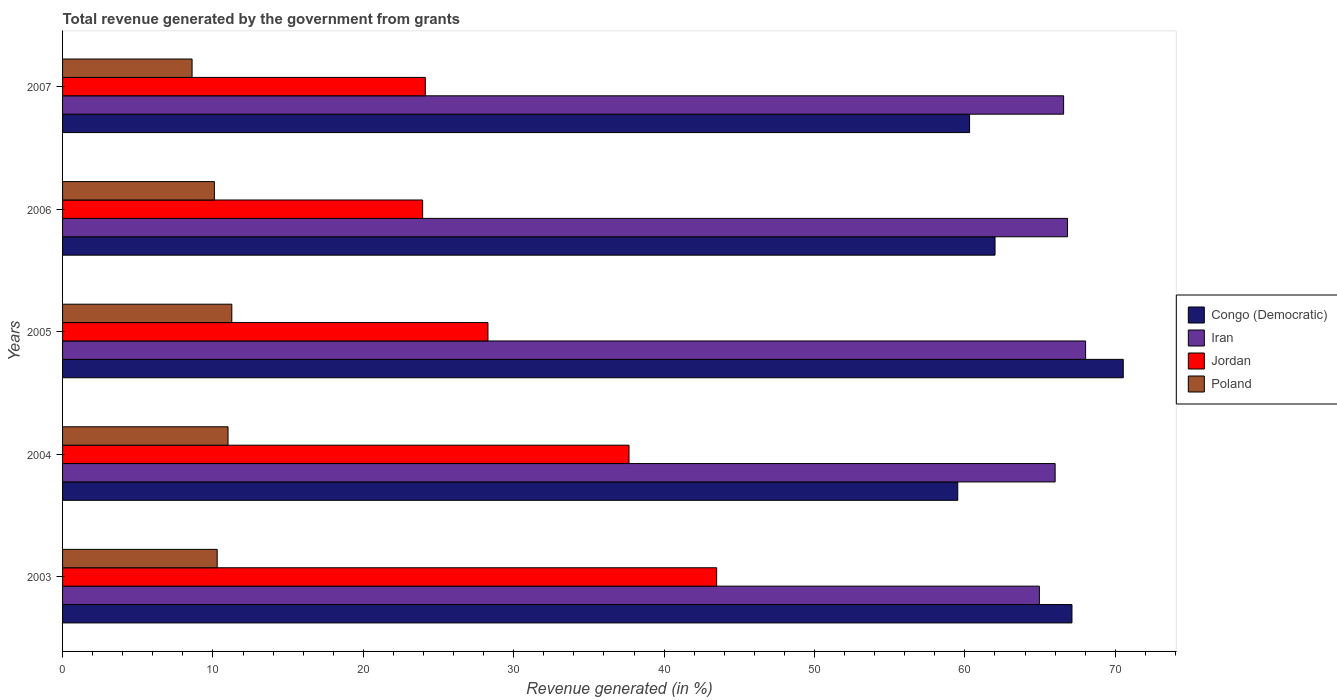Are the number of bars per tick equal to the number of legend labels?
Ensure brevity in your answer.  Yes. How many bars are there on the 5th tick from the top?
Ensure brevity in your answer.  4. How many bars are there on the 1st tick from the bottom?
Keep it short and to the point. 4. What is the label of the 3rd group of bars from the top?
Give a very brief answer. 2005. In how many cases, is the number of bars for a given year not equal to the number of legend labels?
Provide a short and direct response. 0. What is the total revenue generated in Iran in 2006?
Provide a succinct answer. 66.83. Across all years, what is the maximum total revenue generated in Congo (Democratic)?
Offer a terse response. 70.53. Across all years, what is the minimum total revenue generated in Congo (Democratic)?
Provide a short and direct response. 59.53. In which year was the total revenue generated in Congo (Democratic) minimum?
Offer a terse response. 2004. What is the total total revenue generated in Jordan in the graph?
Your response must be concise. 157.51. What is the difference between the total revenue generated in Poland in 2004 and that in 2005?
Your answer should be compact. -0.25. What is the difference between the total revenue generated in Congo (Democratic) in 2004 and the total revenue generated in Jordan in 2007?
Ensure brevity in your answer.  35.41. What is the average total revenue generated in Poland per year?
Ensure brevity in your answer.  10.25. In the year 2004, what is the difference between the total revenue generated in Jordan and total revenue generated in Congo (Democratic)?
Provide a short and direct response. -21.86. In how many years, is the total revenue generated in Poland greater than 48 %?
Offer a terse response. 0. What is the ratio of the total revenue generated in Poland in 2005 to that in 2006?
Ensure brevity in your answer.  1.11. Is the total revenue generated in Iran in 2003 less than that in 2005?
Your response must be concise. Yes. What is the difference between the highest and the second highest total revenue generated in Jordan?
Provide a succinct answer. 5.83. What is the difference between the highest and the lowest total revenue generated in Iran?
Ensure brevity in your answer.  3.07. Is the sum of the total revenue generated in Iran in 2005 and 2006 greater than the maximum total revenue generated in Jordan across all years?
Offer a very short reply. Yes. Is it the case that in every year, the sum of the total revenue generated in Iran and total revenue generated in Poland is greater than the sum of total revenue generated in Congo (Democratic) and total revenue generated in Jordan?
Offer a terse response. No. What does the 1st bar from the top in 2003 represents?
Offer a terse response. Poland. How many bars are there?
Your response must be concise. 20. Are all the bars in the graph horizontal?
Offer a terse response. Yes. How many years are there in the graph?
Offer a very short reply. 5. Are the values on the major ticks of X-axis written in scientific E-notation?
Your answer should be compact. No. How many legend labels are there?
Keep it short and to the point. 4. What is the title of the graph?
Give a very brief answer. Total revenue generated by the government from grants. What is the label or title of the X-axis?
Your answer should be very brief. Revenue generated (in %). What is the label or title of the Y-axis?
Give a very brief answer. Years. What is the Revenue generated (in %) of Congo (Democratic) in 2003?
Provide a succinct answer. 67.12. What is the Revenue generated (in %) of Iran in 2003?
Offer a very short reply. 64.95. What is the Revenue generated (in %) in Jordan in 2003?
Make the answer very short. 43.49. What is the Revenue generated (in %) of Poland in 2003?
Your answer should be compact. 10.28. What is the Revenue generated (in %) in Congo (Democratic) in 2004?
Make the answer very short. 59.53. What is the Revenue generated (in %) of Iran in 2004?
Your answer should be very brief. 66. What is the Revenue generated (in %) of Jordan in 2004?
Offer a very short reply. 37.67. What is the Revenue generated (in %) in Poland in 2004?
Give a very brief answer. 11. What is the Revenue generated (in %) of Congo (Democratic) in 2005?
Your answer should be very brief. 70.53. What is the Revenue generated (in %) in Iran in 2005?
Keep it short and to the point. 68.03. What is the Revenue generated (in %) in Jordan in 2005?
Give a very brief answer. 28.29. What is the Revenue generated (in %) in Poland in 2005?
Provide a succinct answer. 11.25. What is the Revenue generated (in %) of Congo (Democratic) in 2006?
Make the answer very short. 62.01. What is the Revenue generated (in %) in Iran in 2006?
Make the answer very short. 66.83. What is the Revenue generated (in %) in Jordan in 2006?
Your response must be concise. 23.94. What is the Revenue generated (in %) in Poland in 2006?
Keep it short and to the point. 10.09. What is the Revenue generated (in %) in Congo (Democratic) in 2007?
Your answer should be very brief. 60.31. What is the Revenue generated (in %) in Iran in 2007?
Offer a very short reply. 66.57. What is the Revenue generated (in %) of Jordan in 2007?
Keep it short and to the point. 24.12. What is the Revenue generated (in %) of Poland in 2007?
Keep it short and to the point. 8.61. Across all years, what is the maximum Revenue generated (in %) of Congo (Democratic)?
Your answer should be very brief. 70.53. Across all years, what is the maximum Revenue generated (in %) of Iran?
Your answer should be compact. 68.03. Across all years, what is the maximum Revenue generated (in %) of Jordan?
Your response must be concise. 43.49. Across all years, what is the maximum Revenue generated (in %) of Poland?
Ensure brevity in your answer.  11.25. Across all years, what is the minimum Revenue generated (in %) of Congo (Democratic)?
Your answer should be very brief. 59.53. Across all years, what is the minimum Revenue generated (in %) in Iran?
Your response must be concise. 64.95. Across all years, what is the minimum Revenue generated (in %) in Jordan?
Your answer should be very brief. 23.94. Across all years, what is the minimum Revenue generated (in %) of Poland?
Provide a short and direct response. 8.61. What is the total Revenue generated (in %) in Congo (Democratic) in the graph?
Make the answer very short. 319.5. What is the total Revenue generated (in %) in Iran in the graph?
Provide a succinct answer. 332.37. What is the total Revenue generated (in %) of Jordan in the graph?
Give a very brief answer. 157.51. What is the total Revenue generated (in %) of Poland in the graph?
Your response must be concise. 51.24. What is the difference between the Revenue generated (in %) in Congo (Democratic) in 2003 and that in 2004?
Keep it short and to the point. 7.59. What is the difference between the Revenue generated (in %) in Iran in 2003 and that in 2004?
Give a very brief answer. -1.05. What is the difference between the Revenue generated (in %) of Jordan in 2003 and that in 2004?
Your answer should be very brief. 5.83. What is the difference between the Revenue generated (in %) in Poland in 2003 and that in 2004?
Your response must be concise. -0.72. What is the difference between the Revenue generated (in %) of Congo (Democratic) in 2003 and that in 2005?
Offer a terse response. -3.41. What is the difference between the Revenue generated (in %) of Iran in 2003 and that in 2005?
Provide a succinct answer. -3.07. What is the difference between the Revenue generated (in %) in Jordan in 2003 and that in 2005?
Your response must be concise. 15.21. What is the difference between the Revenue generated (in %) in Poland in 2003 and that in 2005?
Offer a terse response. -0.97. What is the difference between the Revenue generated (in %) in Congo (Democratic) in 2003 and that in 2006?
Provide a succinct answer. 5.12. What is the difference between the Revenue generated (in %) in Iran in 2003 and that in 2006?
Make the answer very short. -1.87. What is the difference between the Revenue generated (in %) of Jordan in 2003 and that in 2006?
Your response must be concise. 19.55. What is the difference between the Revenue generated (in %) of Poland in 2003 and that in 2006?
Your answer should be very brief. 0.19. What is the difference between the Revenue generated (in %) in Congo (Democratic) in 2003 and that in 2007?
Keep it short and to the point. 6.81. What is the difference between the Revenue generated (in %) of Iran in 2003 and that in 2007?
Keep it short and to the point. -1.61. What is the difference between the Revenue generated (in %) of Jordan in 2003 and that in 2007?
Keep it short and to the point. 19.37. What is the difference between the Revenue generated (in %) of Poland in 2003 and that in 2007?
Your answer should be very brief. 1.67. What is the difference between the Revenue generated (in %) of Congo (Democratic) in 2004 and that in 2005?
Keep it short and to the point. -11.01. What is the difference between the Revenue generated (in %) of Iran in 2004 and that in 2005?
Your answer should be very brief. -2.03. What is the difference between the Revenue generated (in %) in Jordan in 2004 and that in 2005?
Your response must be concise. 9.38. What is the difference between the Revenue generated (in %) in Poland in 2004 and that in 2005?
Give a very brief answer. -0.25. What is the difference between the Revenue generated (in %) in Congo (Democratic) in 2004 and that in 2006?
Give a very brief answer. -2.48. What is the difference between the Revenue generated (in %) in Iran in 2004 and that in 2006?
Provide a short and direct response. -0.82. What is the difference between the Revenue generated (in %) of Jordan in 2004 and that in 2006?
Your response must be concise. 13.72. What is the difference between the Revenue generated (in %) in Poland in 2004 and that in 2006?
Offer a very short reply. 0.91. What is the difference between the Revenue generated (in %) in Congo (Democratic) in 2004 and that in 2007?
Offer a terse response. -0.78. What is the difference between the Revenue generated (in %) in Iran in 2004 and that in 2007?
Ensure brevity in your answer.  -0.56. What is the difference between the Revenue generated (in %) in Jordan in 2004 and that in 2007?
Your response must be concise. 13.54. What is the difference between the Revenue generated (in %) in Poland in 2004 and that in 2007?
Offer a very short reply. 2.39. What is the difference between the Revenue generated (in %) of Congo (Democratic) in 2005 and that in 2006?
Provide a short and direct response. 8.53. What is the difference between the Revenue generated (in %) in Iran in 2005 and that in 2006?
Your response must be concise. 1.2. What is the difference between the Revenue generated (in %) of Jordan in 2005 and that in 2006?
Ensure brevity in your answer.  4.34. What is the difference between the Revenue generated (in %) in Poland in 2005 and that in 2006?
Your answer should be very brief. 1.16. What is the difference between the Revenue generated (in %) in Congo (Democratic) in 2005 and that in 2007?
Give a very brief answer. 10.22. What is the difference between the Revenue generated (in %) in Iran in 2005 and that in 2007?
Your answer should be very brief. 1.46. What is the difference between the Revenue generated (in %) in Jordan in 2005 and that in 2007?
Offer a very short reply. 4.16. What is the difference between the Revenue generated (in %) in Poland in 2005 and that in 2007?
Make the answer very short. 2.64. What is the difference between the Revenue generated (in %) of Congo (Democratic) in 2006 and that in 2007?
Make the answer very short. 1.69. What is the difference between the Revenue generated (in %) of Iran in 2006 and that in 2007?
Your answer should be very brief. 0.26. What is the difference between the Revenue generated (in %) in Jordan in 2006 and that in 2007?
Your response must be concise. -0.18. What is the difference between the Revenue generated (in %) in Poland in 2006 and that in 2007?
Provide a short and direct response. 1.48. What is the difference between the Revenue generated (in %) of Congo (Democratic) in 2003 and the Revenue generated (in %) of Iran in 2004?
Ensure brevity in your answer.  1.12. What is the difference between the Revenue generated (in %) of Congo (Democratic) in 2003 and the Revenue generated (in %) of Jordan in 2004?
Your response must be concise. 29.45. What is the difference between the Revenue generated (in %) in Congo (Democratic) in 2003 and the Revenue generated (in %) in Poland in 2004?
Offer a terse response. 56.12. What is the difference between the Revenue generated (in %) of Iran in 2003 and the Revenue generated (in %) of Jordan in 2004?
Make the answer very short. 27.29. What is the difference between the Revenue generated (in %) in Iran in 2003 and the Revenue generated (in %) in Poland in 2004?
Make the answer very short. 53.95. What is the difference between the Revenue generated (in %) of Jordan in 2003 and the Revenue generated (in %) of Poland in 2004?
Make the answer very short. 32.49. What is the difference between the Revenue generated (in %) in Congo (Democratic) in 2003 and the Revenue generated (in %) in Iran in 2005?
Ensure brevity in your answer.  -0.91. What is the difference between the Revenue generated (in %) in Congo (Democratic) in 2003 and the Revenue generated (in %) in Jordan in 2005?
Your answer should be very brief. 38.83. What is the difference between the Revenue generated (in %) in Congo (Democratic) in 2003 and the Revenue generated (in %) in Poland in 2005?
Your answer should be very brief. 55.87. What is the difference between the Revenue generated (in %) of Iran in 2003 and the Revenue generated (in %) of Jordan in 2005?
Provide a short and direct response. 36.67. What is the difference between the Revenue generated (in %) of Iran in 2003 and the Revenue generated (in %) of Poland in 2005?
Your answer should be very brief. 53.7. What is the difference between the Revenue generated (in %) in Jordan in 2003 and the Revenue generated (in %) in Poland in 2005?
Your response must be concise. 32.24. What is the difference between the Revenue generated (in %) of Congo (Democratic) in 2003 and the Revenue generated (in %) of Iran in 2006?
Offer a very short reply. 0.3. What is the difference between the Revenue generated (in %) of Congo (Democratic) in 2003 and the Revenue generated (in %) of Jordan in 2006?
Keep it short and to the point. 43.18. What is the difference between the Revenue generated (in %) in Congo (Democratic) in 2003 and the Revenue generated (in %) in Poland in 2006?
Offer a very short reply. 57.03. What is the difference between the Revenue generated (in %) in Iran in 2003 and the Revenue generated (in %) in Jordan in 2006?
Make the answer very short. 41.01. What is the difference between the Revenue generated (in %) in Iran in 2003 and the Revenue generated (in %) in Poland in 2006?
Ensure brevity in your answer.  54.86. What is the difference between the Revenue generated (in %) of Jordan in 2003 and the Revenue generated (in %) of Poland in 2006?
Provide a short and direct response. 33.4. What is the difference between the Revenue generated (in %) of Congo (Democratic) in 2003 and the Revenue generated (in %) of Iran in 2007?
Provide a short and direct response. 0.55. What is the difference between the Revenue generated (in %) of Congo (Democratic) in 2003 and the Revenue generated (in %) of Jordan in 2007?
Your answer should be very brief. 43. What is the difference between the Revenue generated (in %) in Congo (Democratic) in 2003 and the Revenue generated (in %) in Poland in 2007?
Provide a succinct answer. 58.51. What is the difference between the Revenue generated (in %) of Iran in 2003 and the Revenue generated (in %) of Jordan in 2007?
Provide a succinct answer. 40.83. What is the difference between the Revenue generated (in %) in Iran in 2003 and the Revenue generated (in %) in Poland in 2007?
Your response must be concise. 56.34. What is the difference between the Revenue generated (in %) in Jordan in 2003 and the Revenue generated (in %) in Poland in 2007?
Offer a very short reply. 34.88. What is the difference between the Revenue generated (in %) of Congo (Democratic) in 2004 and the Revenue generated (in %) of Iran in 2005?
Give a very brief answer. -8.5. What is the difference between the Revenue generated (in %) of Congo (Democratic) in 2004 and the Revenue generated (in %) of Jordan in 2005?
Your answer should be compact. 31.24. What is the difference between the Revenue generated (in %) of Congo (Democratic) in 2004 and the Revenue generated (in %) of Poland in 2005?
Offer a terse response. 48.27. What is the difference between the Revenue generated (in %) of Iran in 2004 and the Revenue generated (in %) of Jordan in 2005?
Provide a succinct answer. 37.72. What is the difference between the Revenue generated (in %) of Iran in 2004 and the Revenue generated (in %) of Poland in 2005?
Give a very brief answer. 54.75. What is the difference between the Revenue generated (in %) in Jordan in 2004 and the Revenue generated (in %) in Poland in 2005?
Ensure brevity in your answer.  26.41. What is the difference between the Revenue generated (in %) in Congo (Democratic) in 2004 and the Revenue generated (in %) in Iran in 2006?
Offer a terse response. -7.3. What is the difference between the Revenue generated (in %) of Congo (Democratic) in 2004 and the Revenue generated (in %) of Jordan in 2006?
Give a very brief answer. 35.58. What is the difference between the Revenue generated (in %) in Congo (Democratic) in 2004 and the Revenue generated (in %) in Poland in 2006?
Make the answer very short. 49.43. What is the difference between the Revenue generated (in %) of Iran in 2004 and the Revenue generated (in %) of Jordan in 2006?
Give a very brief answer. 42.06. What is the difference between the Revenue generated (in %) of Iran in 2004 and the Revenue generated (in %) of Poland in 2006?
Your response must be concise. 55.91. What is the difference between the Revenue generated (in %) in Jordan in 2004 and the Revenue generated (in %) in Poland in 2006?
Your answer should be very brief. 27.57. What is the difference between the Revenue generated (in %) of Congo (Democratic) in 2004 and the Revenue generated (in %) of Iran in 2007?
Keep it short and to the point. -7.04. What is the difference between the Revenue generated (in %) of Congo (Democratic) in 2004 and the Revenue generated (in %) of Jordan in 2007?
Make the answer very short. 35.41. What is the difference between the Revenue generated (in %) in Congo (Democratic) in 2004 and the Revenue generated (in %) in Poland in 2007?
Provide a short and direct response. 50.92. What is the difference between the Revenue generated (in %) in Iran in 2004 and the Revenue generated (in %) in Jordan in 2007?
Ensure brevity in your answer.  41.88. What is the difference between the Revenue generated (in %) in Iran in 2004 and the Revenue generated (in %) in Poland in 2007?
Offer a terse response. 57.39. What is the difference between the Revenue generated (in %) of Jordan in 2004 and the Revenue generated (in %) of Poland in 2007?
Provide a succinct answer. 29.05. What is the difference between the Revenue generated (in %) of Congo (Democratic) in 2005 and the Revenue generated (in %) of Iran in 2006?
Your answer should be very brief. 3.71. What is the difference between the Revenue generated (in %) in Congo (Democratic) in 2005 and the Revenue generated (in %) in Jordan in 2006?
Provide a short and direct response. 46.59. What is the difference between the Revenue generated (in %) of Congo (Democratic) in 2005 and the Revenue generated (in %) of Poland in 2006?
Ensure brevity in your answer.  60.44. What is the difference between the Revenue generated (in %) of Iran in 2005 and the Revenue generated (in %) of Jordan in 2006?
Your answer should be compact. 44.08. What is the difference between the Revenue generated (in %) of Iran in 2005 and the Revenue generated (in %) of Poland in 2006?
Provide a succinct answer. 57.93. What is the difference between the Revenue generated (in %) in Jordan in 2005 and the Revenue generated (in %) in Poland in 2006?
Your answer should be very brief. 18.19. What is the difference between the Revenue generated (in %) in Congo (Democratic) in 2005 and the Revenue generated (in %) in Iran in 2007?
Make the answer very short. 3.97. What is the difference between the Revenue generated (in %) of Congo (Democratic) in 2005 and the Revenue generated (in %) of Jordan in 2007?
Give a very brief answer. 46.41. What is the difference between the Revenue generated (in %) in Congo (Democratic) in 2005 and the Revenue generated (in %) in Poland in 2007?
Offer a very short reply. 61.92. What is the difference between the Revenue generated (in %) in Iran in 2005 and the Revenue generated (in %) in Jordan in 2007?
Ensure brevity in your answer.  43.91. What is the difference between the Revenue generated (in %) of Iran in 2005 and the Revenue generated (in %) of Poland in 2007?
Provide a short and direct response. 59.42. What is the difference between the Revenue generated (in %) of Jordan in 2005 and the Revenue generated (in %) of Poland in 2007?
Offer a very short reply. 19.68. What is the difference between the Revenue generated (in %) of Congo (Democratic) in 2006 and the Revenue generated (in %) of Iran in 2007?
Provide a short and direct response. -4.56. What is the difference between the Revenue generated (in %) of Congo (Democratic) in 2006 and the Revenue generated (in %) of Jordan in 2007?
Provide a succinct answer. 37.88. What is the difference between the Revenue generated (in %) of Congo (Democratic) in 2006 and the Revenue generated (in %) of Poland in 2007?
Offer a very short reply. 53.39. What is the difference between the Revenue generated (in %) in Iran in 2006 and the Revenue generated (in %) in Jordan in 2007?
Offer a terse response. 42.7. What is the difference between the Revenue generated (in %) in Iran in 2006 and the Revenue generated (in %) in Poland in 2007?
Provide a succinct answer. 58.21. What is the difference between the Revenue generated (in %) of Jordan in 2006 and the Revenue generated (in %) of Poland in 2007?
Your answer should be compact. 15.33. What is the average Revenue generated (in %) in Congo (Democratic) per year?
Offer a very short reply. 63.9. What is the average Revenue generated (in %) in Iran per year?
Give a very brief answer. 66.47. What is the average Revenue generated (in %) of Jordan per year?
Keep it short and to the point. 31.5. What is the average Revenue generated (in %) of Poland per year?
Provide a succinct answer. 10.25. In the year 2003, what is the difference between the Revenue generated (in %) of Congo (Democratic) and Revenue generated (in %) of Iran?
Provide a short and direct response. 2.17. In the year 2003, what is the difference between the Revenue generated (in %) in Congo (Democratic) and Revenue generated (in %) in Jordan?
Offer a very short reply. 23.63. In the year 2003, what is the difference between the Revenue generated (in %) in Congo (Democratic) and Revenue generated (in %) in Poland?
Your answer should be compact. 56.84. In the year 2003, what is the difference between the Revenue generated (in %) in Iran and Revenue generated (in %) in Jordan?
Make the answer very short. 21.46. In the year 2003, what is the difference between the Revenue generated (in %) in Iran and Revenue generated (in %) in Poland?
Offer a very short reply. 54.67. In the year 2003, what is the difference between the Revenue generated (in %) of Jordan and Revenue generated (in %) of Poland?
Provide a short and direct response. 33.21. In the year 2004, what is the difference between the Revenue generated (in %) of Congo (Democratic) and Revenue generated (in %) of Iran?
Offer a very short reply. -6.47. In the year 2004, what is the difference between the Revenue generated (in %) of Congo (Democratic) and Revenue generated (in %) of Jordan?
Offer a very short reply. 21.86. In the year 2004, what is the difference between the Revenue generated (in %) of Congo (Democratic) and Revenue generated (in %) of Poland?
Offer a terse response. 48.52. In the year 2004, what is the difference between the Revenue generated (in %) in Iran and Revenue generated (in %) in Jordan?
Keep it short and to the point. 28.34. In the year 2004, what is the difference between the Revenue generated (in %) in Iran and Revenue generated (in %) in Poland?
Provide a succinct answer. 55. In the year 2004, what is the difference between the Revenue generated (in %) of Jordan and Revenue generated (in %) of Poland?
Keep it short and to the point. 26.66. In the year 2005, what is the difference between the Revenue generated (in %) of Congo (Democratic) and Revenue generated (in %) of Iran?
Ensure brevity in your answer.  2.51. In the year 2005, what is the difference between the Revenue generated (in %) in Congo (Democratic) and Revenue generated (in %) in Jordan?
Keep it short and to the point. 42.25. In the year 2005, what is the difference between the Revenue generated (in %) in Congo (Democratic) and Revenue generated (in %) in Poland?
Provide a short and direct response. 59.28. In the year 2005, what is the difference between the Revenue generated (in %) in Iran and Revenue generated (in %) in Jordan?
Make the answer very short. 39.74. In the year 2005, what is the difference between the Revenue generated (in %) in Iran and Revenue generated (in %) in Poland?
Offer a terse response. 56.77. In the year 2005, what is the difference between the Revenue generated (in %) of Jordan and Revenue generated (in %) of Poland?
Provide a short and direct response. 17.03. In the year 2006, what is the difference between the Revenue generated (in %) in Congo (Democratic) and Revenue generated (in %) in Iran?
Your response must be concise. -4.82. In the year 2006, what is the difference between the Revenue generated (in %) in Congo (Democratic) and Revenue generated (in %) in Jordan?
Offer a very short reply. 38.06. In the year 2006, what is the difference between the Revenue generated (in %) of Congo (Democratic) and Revenue generated (in %) of Poland?
Ensure brevity in your answer.  51.91. In the year 2006, what is the difference between the Revenue generated (in %) in Iran and Revenue generated (in %) in Jordan?
Your response must be concise. 42.88. In the year 2006, what is the difference between the Revenue generated (in %) in Iran and Revenue generated (in %) in Poland?
Your answer should be very brief. 56.73. In the year 2006, what is the difference between the Revenue generated (in %) in Jordan and Revenue generated (in %) in Poland?
Your response must be concise. 13.85. In the year 2007, what is the difference between the Revenue generated (in %) of Congo (Democratic) and Revenue generated (in %) of Iran?
Provide a short and direct response. -6.25. In the year 2007, what is the difference between the Revenue generated (in %) of Congo (Democratic) and Revenue generated (in %) of Jordan?
Your answer should be very brief. 36.19. In the year 2007, what is the difference between the Revenue generated (in %) of Congo (Democratic) and Revenue generated (in %) of Poland?
Keep it short and to the point. 51.7. In the year 2007, what is the difference between the Revenue generated (in %) of Iran and Revenue generated (in %) of Jordan?
Provide a short and direct response. 42.44. In the year 2007, what is the difference between the Revenue generated (in %) of Iran and Revenue generated (in %) of Poland?
Offer a very short reply. 57.95. In the year 2007, what is the difference between the Revenue generated (in %) in Jordan and Revenue generated (in %) in Poland?
Keep it short and to the point. 15.51. What is the ratio of the Revenue generated (in %) in Congo (Democratic) in 2003 to that in 2004?
Ensure brevity in your answer.  1.13. What is the ratio of the Revenue generated (in %) of Iran in 2003 to that in 2004?
Make the answer very short. 0.98. What is the ratio of the Revenue generated (in %) in Jordan in 2003 to that in 2004?
Ensure brevity in your answer.  1.15. What is the ratio of the Revenue generated (in %) of Poland in 2003 to that in 2004?
Keep it short and to the point. 0.93. What is the ratio of the Revenue generated (in %) of Congo (Democratic) in 2003 to that in 2005?
Your answer should be very brief. 0.95. What is the ratio of the Revenue generated (in %) of Iran in 2003 to that in 2005?
Your answer should be compact. 0.95. What is the ratio of the Revenue generated (in %) in Jordan in 2003 to that in 2005?
Keep it short and to the point. 1.54. What is the ratio of the Revenue generated (in %) in Poland in 2003 to that in 2005?
Offer a terse response. 0.91. What is the ratio of the Revenue generated (in %) of Congo (Democratic) in 2003 to that in 2006?
Make the answer very short. 1.08. What is the ratio of the Revenue generated (in %) of Jordan in 2003 to that in 2006?
Keep it short and to the point. 1.82. What is the ratio of the Revenue generated (in %) of Poland in 2003 to that in 2006?
Offer a terse response. 1.02. What is the ratio of the Revenue generated (in %) of Congo (Democratic) in 2003 to that in 2007?
Offer a very short reply. 1.11. What is the ratio of the Revenue generated (in %) of Iran in 2003 to that in 2007?
Give a very brief answer. 0.98. What is the ratio of the Revenue generated (in %) in Jordan in 2003 to that in 2007?
Offer a terse response. 1.8. What is the ratio of the Revenue generated (in %) of Poland in 2003 to that in 2007?
Keep it short and to the point. 1.19. What is the ratio of the Revenue generated (in %) of Congo (Democratic) in 2004 to that in 2005?
Offer a very short reply. 0.84. What is the ratio of the Revenue generated (in %) in Iran in 2004 to that in 2005?
Your response must be concise. 0.97. What is the ratio of the Revenue generated (in %) of Jordan in 2004 to that in 2005?
Your response must be concise. 1.33. What is the ratio of the Revenue generated (in %) of Poland in 2004 to that in 2005?
Ensure brevity in your answer.  0.98. What is the ratio of the Revenue generated (in %) of Congo (Democratic) in 2004 to that in 2006?
Your response must be concise. 0.96. What is the ratio of the Revenue generated (in %) in Iran in 2004 to that in 2006?
Your response must be concise. 0.99. What is the ratio of the Revenue generated (in %) in Jordan in 2004 to that in 2006?
Your response must be concise. 1.57. What is the ratio of the Revenue generated (in %) in Poland in 2004 to that in 2006?
Your response must be concise. 1.09. What is the ratio of the Revenue generated (in %) in Congo (Democratic) in 2004 to that in 2007?
Keep it short and to the point. 0.99. What is the ratio of the Revenue generated (in %) in Iran in 2004 to that in 2007?
Your answer should be compact. 0.99. What is the ratio of the Revenue generated (in %) of Jordan in 2004 to that in 2007?
Give a very brief answer. 1.56. What is the ratio of the Revenue generated (in %) in Poland in 2004 to that in 2007?
Your answer should be compact. 1.28. What is the ratio of the Revenue generated (in %) of Congo (Democratic) in 2005 to that in 2006?
Keep it short and to the point. 1.14. What is the ratio of the Revenue generated (in %) in Jordan in 2005 to that in 2006?
Provide a succinct answer. 1.18. What is the ratio of the Revenue generated (in %) of Poland in 2005 to that in 2006?
Provide a succinct answer. 1.11. What is the ratio of the Revenue generated (in %) in Congo (Democratic) in 2005 to that in 2007?
Give a very brief answer. 1.17. What is the ratio of the Revenue generated (in %) of Jordan in 2005 to that in 2007?
Offer a very short reply. 1.17. What is the ratio of the Revenue generated (in %) in Poland in 2005 to that in 2007?
Provide a short and direct response. 1.31. What is the ratio of the Revenue generated (in %) in Congo (Democratic) in 2006 to that in 2007?
Your answer should be very brief. 1.03. What is the ratio of the Revenue generated (in %) in Jordan in 2006 to that in 2007?
Ensure brevity in your answer.  0.99. What is the ratio of the Revenue generated (in %) of Poland in 2006 to that in 2007?
Offer a terse response. 1.17. What is the difference between the highest and the second highest Revenue generated (in %) in Congo (Democratic)?
Offer a very short reply. 3.41. What is the difference between the highest and the second highest Revenue generated (in %) in Iran?
Your response must be concise. 1.2. What is the difference between the highest and the second highest Revenue generated (in %) of Jordan?
Your answer should be very brief. 5.83. What is the difference between the highest and the second highest Revenue generated (in %) in Poland?
Your response must be concise. 0.25. What is the difference between the highest and the lowest Revenue generated (in %) of Congo (Democratic)?
Your answer should be very brief. 11.01. What is the difference between the highest and the lowest Revenue generated (in %) in Iran?
Provide a succinct answer. 3.07. What is the difference between the highest and the lowest Revenue generated (in %) of Jordan?
Your response must be concise. 19.55. What is the difference between the highest and the lowest Revenue generated (in %) in Poland?
Ensure brevity in your answer.  2.64. 